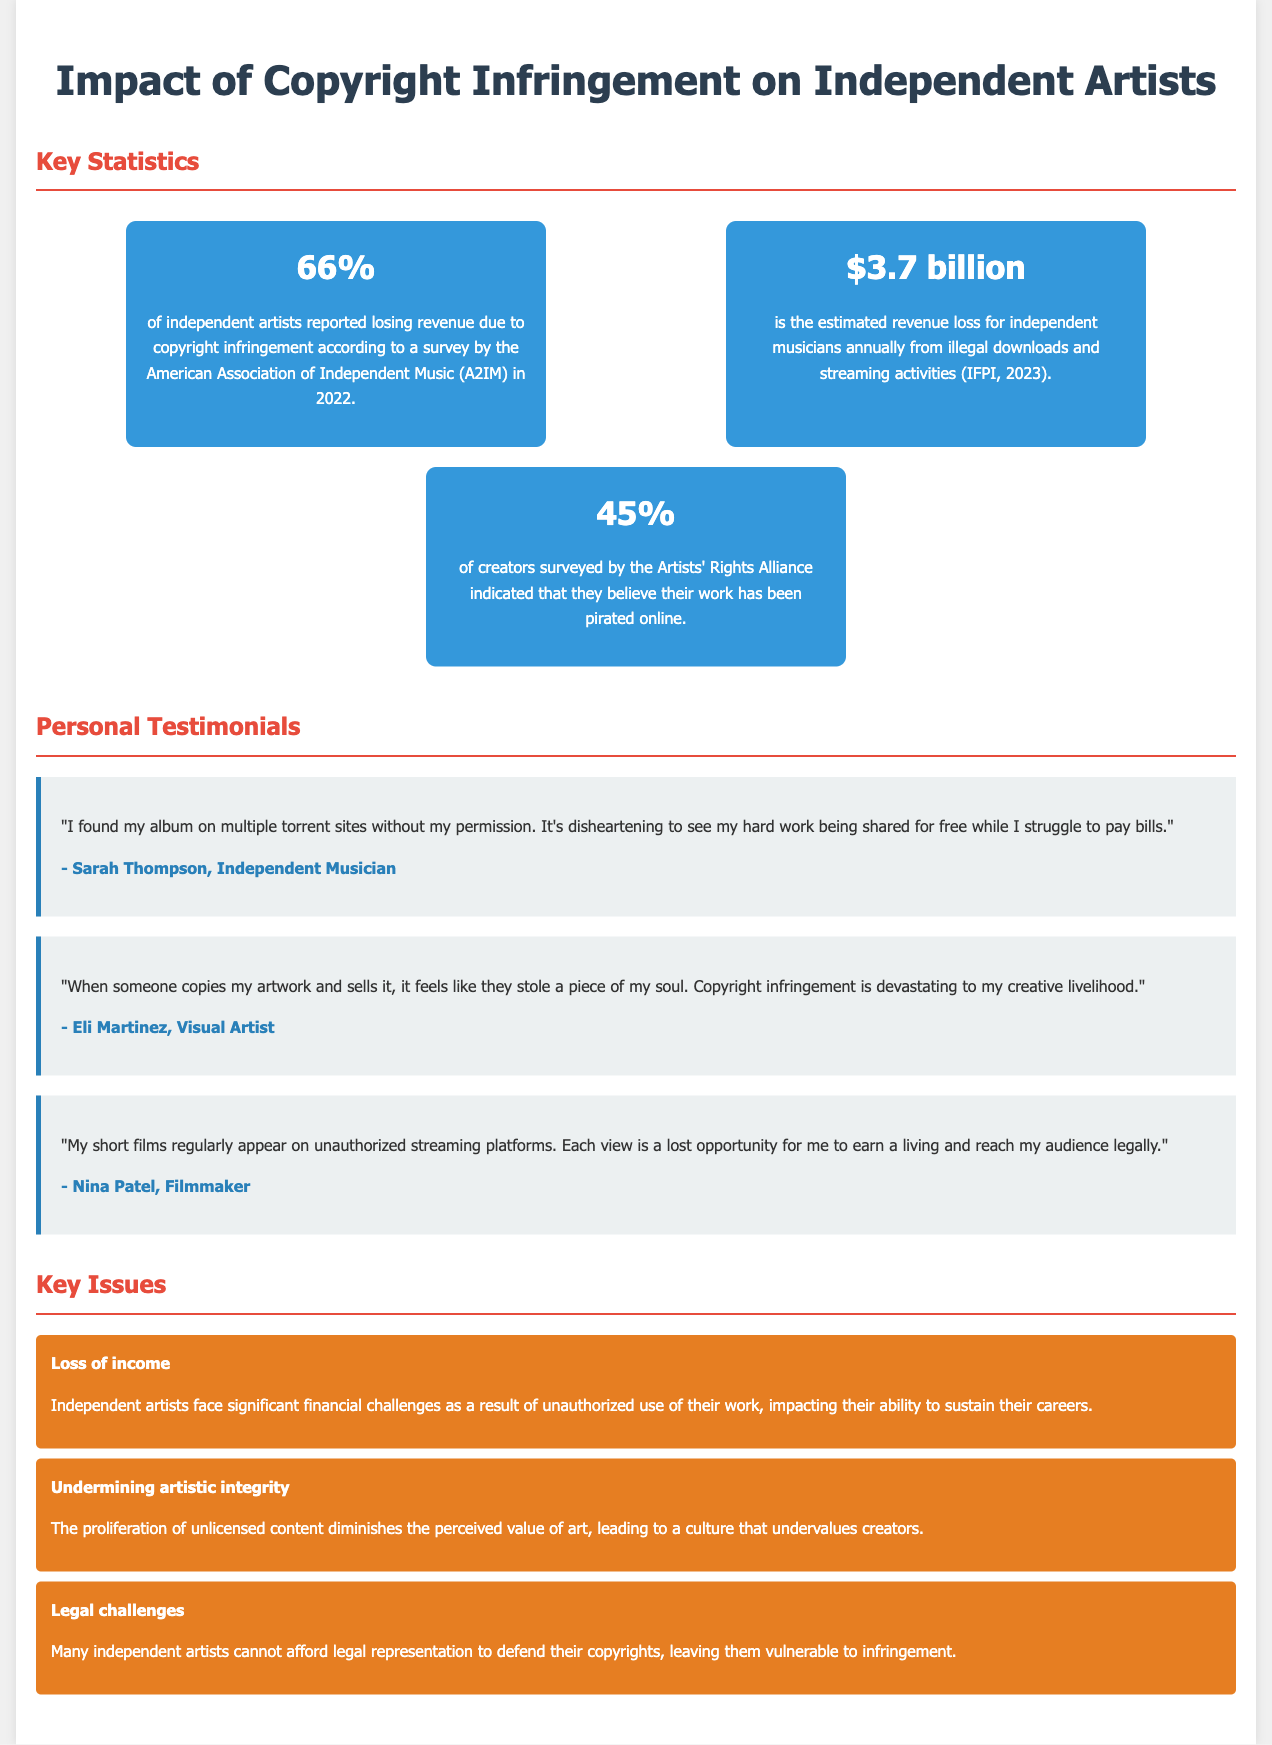what percentage of independent artists reported losing revenue? The document states that 66% of independent artists reported losing revenue due to copyright infringement.
Answer: 66% what is the estimated annual revenue loss for independent musicians? The estimated revenue loss is presented as $3.7 billion in the document.
Answer: $3.7 billion who expressed feelings of loss when their artwork was copied? The document includes a testimonial from Eli Martinez who expressed these feelings.
Answer: Eli Martinez what percentage of surveyed creators believe their work has been pirated? The document indicates that 45% of creators surveyed believe their work has been pirated online.
Answer: 45% what is one issue independent artists face due to copyright infringement? The document mentions that loss of income is a significant issue for independent artists.
Answer: Loss of income why might independent artists struggle legally against copyright infringement? The document states that many independent artists cannot afford legal representation to defend their copyrights.
Answer: Cannot afford legal representation which group conducted a survey reporting the 66% statistic? The document attributes this statistic to the American Association of Independent Music (A2IM).
Answer: American Association of Independent Music (A2IM) who is quoted as saying their album was found on torrent sites without permission? Sarah Thompson is quoted in the document regarding her album found on torrent sites without permission.
Answer: Sarah Thompson 